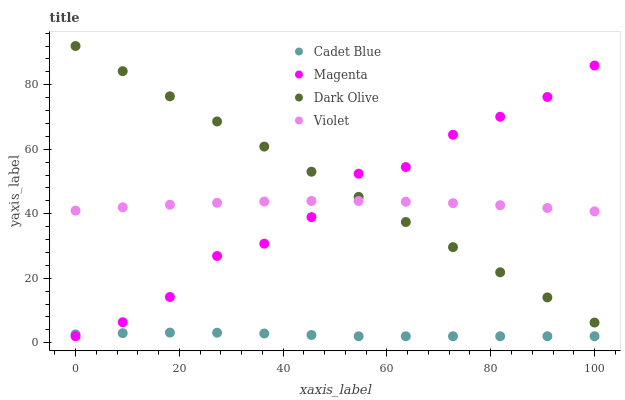Does Cadet Blue have the minimum area under the curve?
Answer yes or no. Yes. Does Dark Olive have the maximum area under the curve?
Answer yes or no. Yes. Does Magenta have the minimum area under the curve?
Answer yes or no. No. Does Magenta have the maximum area under the curve?
Answer yes or no. No. Is Dark Olive the smoothest?
Answer yes or no. Yes. Is Magenta the roughest?
Answer yes or no. Yes. Is Cadet Blue the smoothest?
Answer yes or no. No. Is Cadet Blue the roughest?
Answer yes or no. No. Does Magenta have the lowest value?
Answer yes or no. Yes. Does Violet have the lowest value?
Answer yes or no. No. Does Dark Olive have the highest value?
Answer yes or no. Yes. Does Magenta have the highest value?
Answer yes or no. No. Is Cadet Blue less than Violet?
Answer yes or no. Yes. Is Violet greater than Cadet Blue?
Answer yes or no. Yes. Does Magenta intersect Cadet Blue?
Answer yes or no. Yes. Is Magenta less than Cadet Blue?
Answer yes or no. No. Is Magenta greater than Cadet Blue?
Answer yes or no. No. Does Cadet Blue intersect Violet?
Answer yes or no. No. 